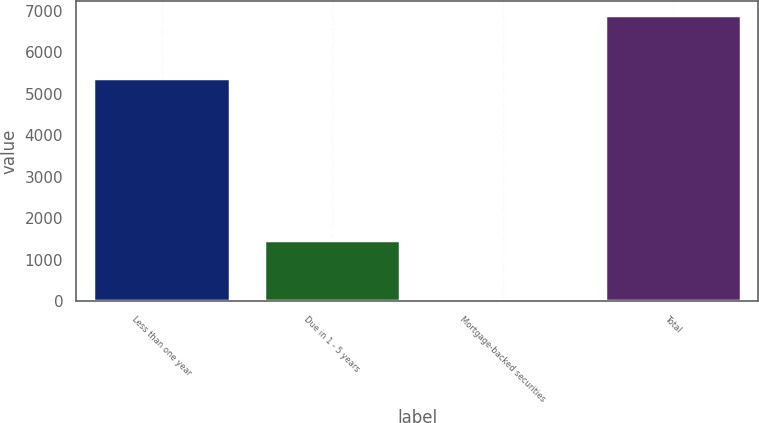Convert chart to OTSL. <chart><loc_0><loc_0><loc_500><loc_500><bar_chart><fcel>Less than one year<fcel>Due in 1 - 5 years<fcel>Mortgage-backed securities<fcel>Total<nl><fcel>5375<fcel>1485<fcel>35<fcel>6895<nl></chart> 